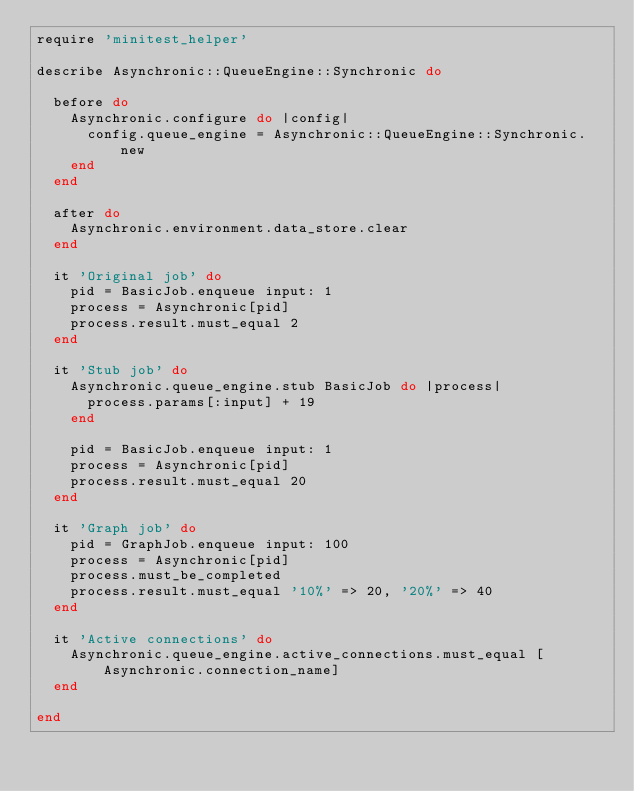Convert code to text. <code><loc_0><loc_0><loc_500><loc_500><_Ruby_>require 'minitest_helper'

describe Asynchronic::QueueEngine::Synchronic do

  before do
    Asynchronic.configure do |config|
      config.queue_engine = Asynchronic::QueueEngine::Synchronic.new
    end
  end

  after do
    Asynchronic.environment.data_store.clear
  end

  it 'Original job' do
    pid = BasicJob.enqueue input: 1
    process = Asynchronic[pid]
    process.result.must_equal 2
  end

  it 'Stub job' do
    Asynchronic.queue_engine.stub BasicJob do |process|
      process.params[:input] + 19
    end

    pid = BasicJob.enqueue input: 1
    process = Asynchronic[pid]
    process.result.must_equal 20
  end

  it 'Graph job' do
    pid = GraphJob.enqueue input: 100
    process = Asynchronic[pid]
    process.must_be_completed
    process.result.must_equal '10%' => 20, '20%' => 40
  end

  it 'Active connections' do
    Asynchronic.queue_engine.active_connections.must_equal [Asynchronic.connection_name]
  end

end</code> 